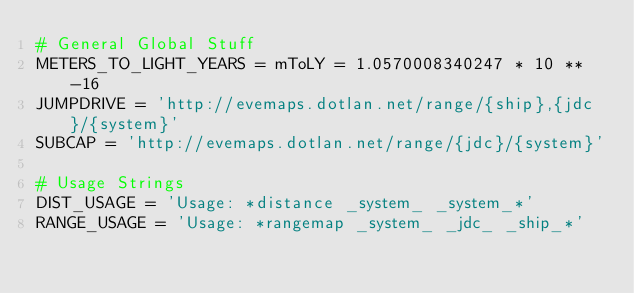<code> <loc_0><loc_0><loc_500><loc_500><_Python_># General Global Stuff
METERS_TO_LIGHT_YEARS = mToLY = 1.0570008340247 * 10 ** -16
JUMPDRIVE = 'http://evemaps.dotlan.net/range/{ship},{jdc}/{system}'
SUBCAP = 'http://evemaps.dotlan.net/range/{jdc}/{system}'

# Usage Strings
DIST_USAGE = 'Usage: *distance _system_ _system_*'
RANGE_USAGE = 'Usage: *rangemap _system_ _jdc_ _ship_*'
</code> 